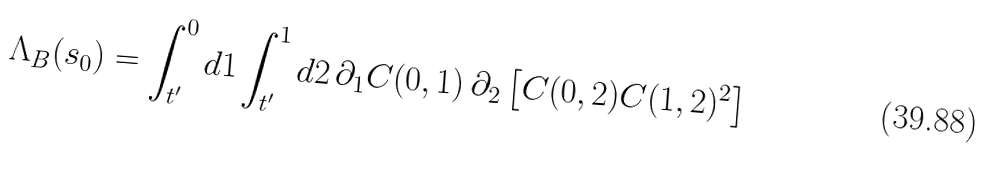Convert formula to latex. <formula><loc_0><loc_0><loc_500><loc_500>\Lambda _ { B } ( s _ { 0 } ) = \int _ { t ^ { \prime } } ^ { 0 } d 1 \int _ { t ^ { \prime } } ^ { 1 } d 2 \, \partial _ { 1 } C ( 0 , 1 ) \, \partial _ { 2 } \left [ C ( 0 , 2 ) C ( 1 , 2 ) ^ { 2 } \right ]</formula> 